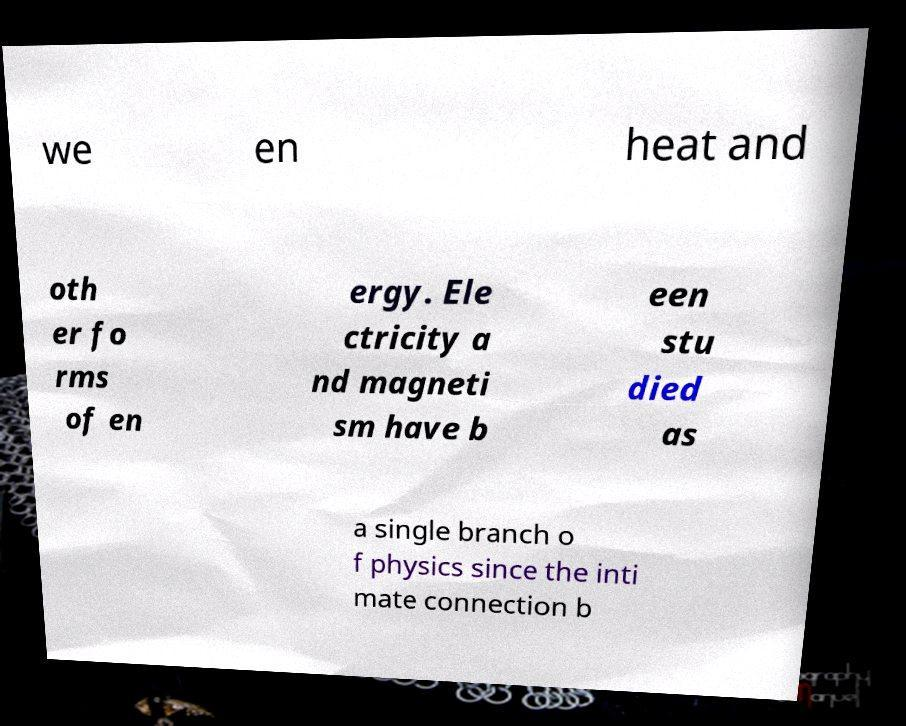For documentation purposes, I need the text within this image transcribed. Could you provide that? we en heat and oth er fo rms of en ergy. Ele ctricity a nd magneti sm have b een stu died as a single branch o f physics since the inti mate connection b 